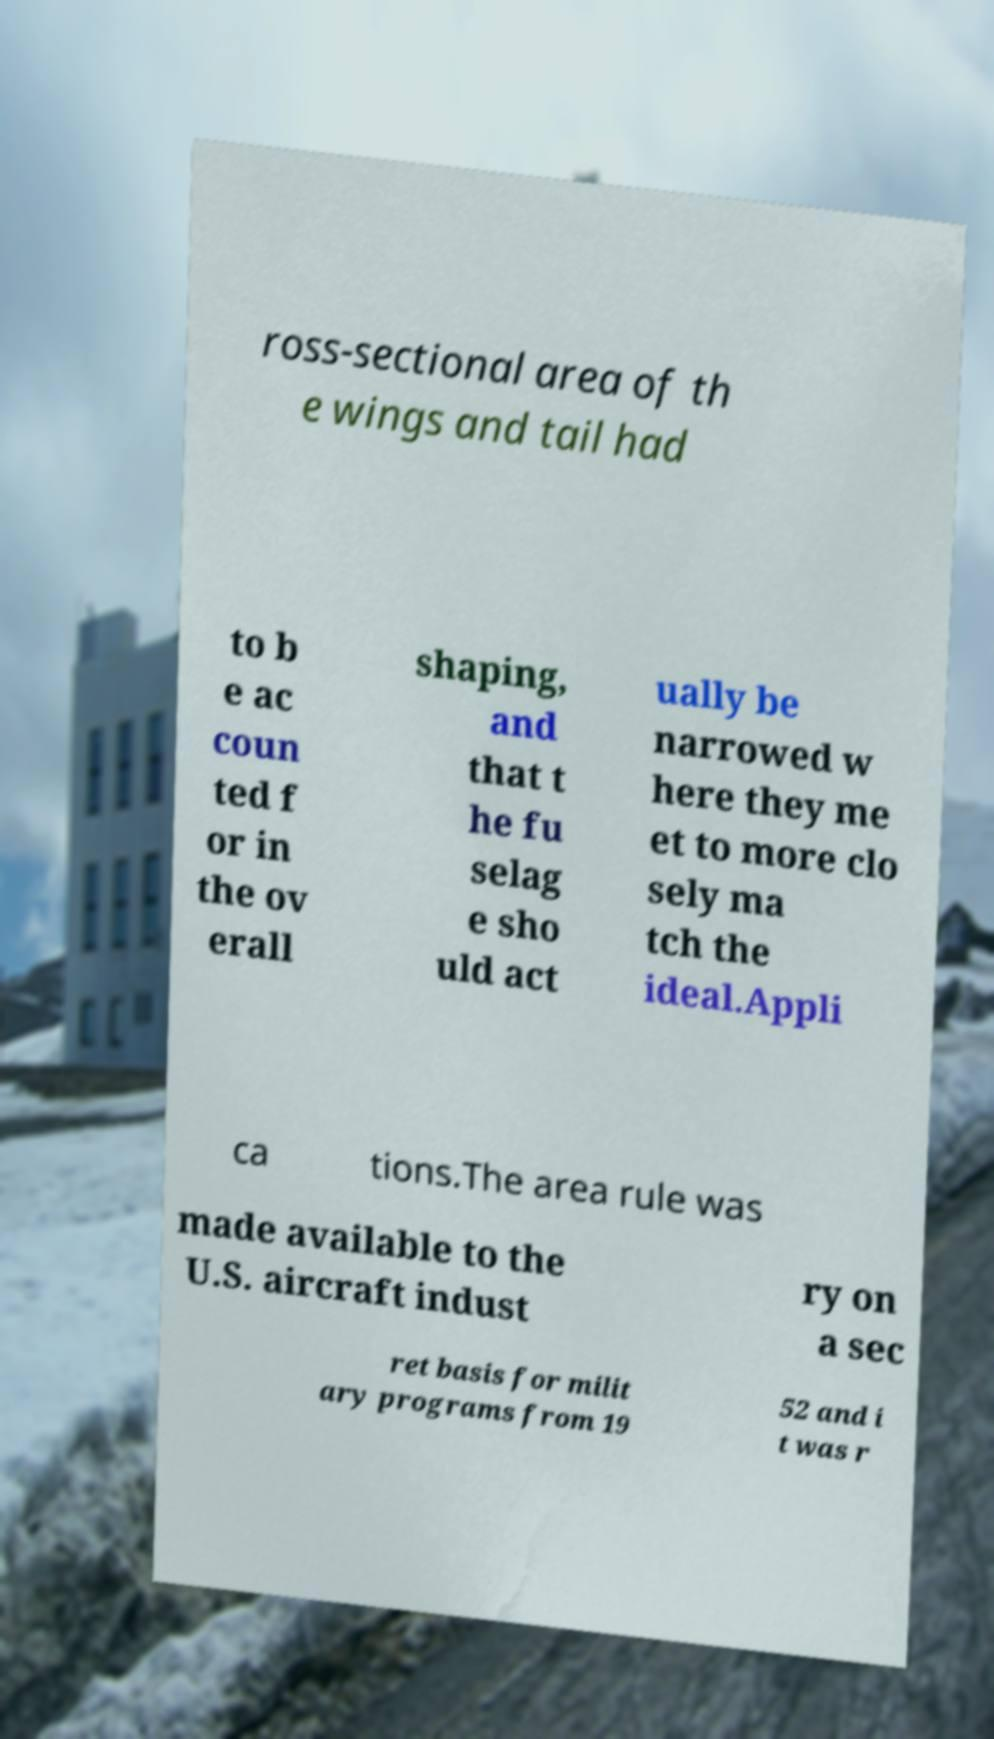Please read and relay the text visible in this image. What does it say? ross-sectional area of th e wings and tail had to b e ac coun ted f or in the ov erall shaping, and that t he fu selag e sho uld act ually be narrowed w here they me et to more clo sely ma tch the ideal.Appli ca tions.The area rule was made available to the U.S. aircraft indust ry on a sec ret basis for milit ary programs from 19 52 and i t was r 